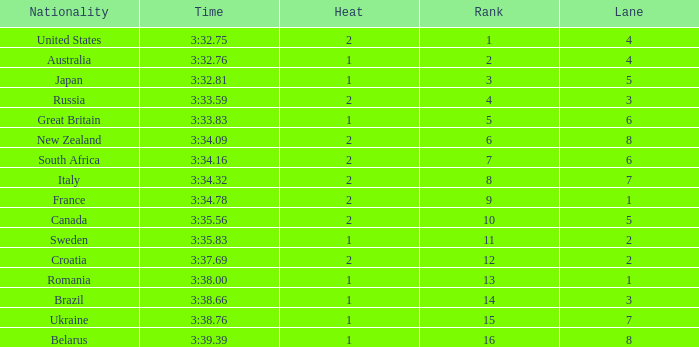Can you tell me the Rank that has the Lane of 6, and the Heat of 2? 7.0. 